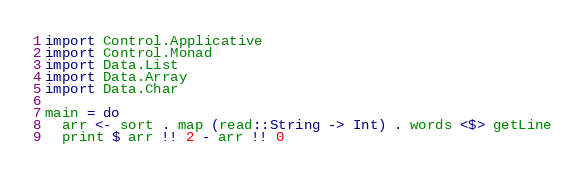<code> <loc_0><loc_0><loc_500><loc_500><_Haskell_>import Control.Applicative
import Control.Monad
import Data.List
import Data.Array
import Data.Char

main = do
  arr <- sort . map (read::String -> Int) . words <$> getLine
  print $ arr !! 2 - arr !! 0
</code> 